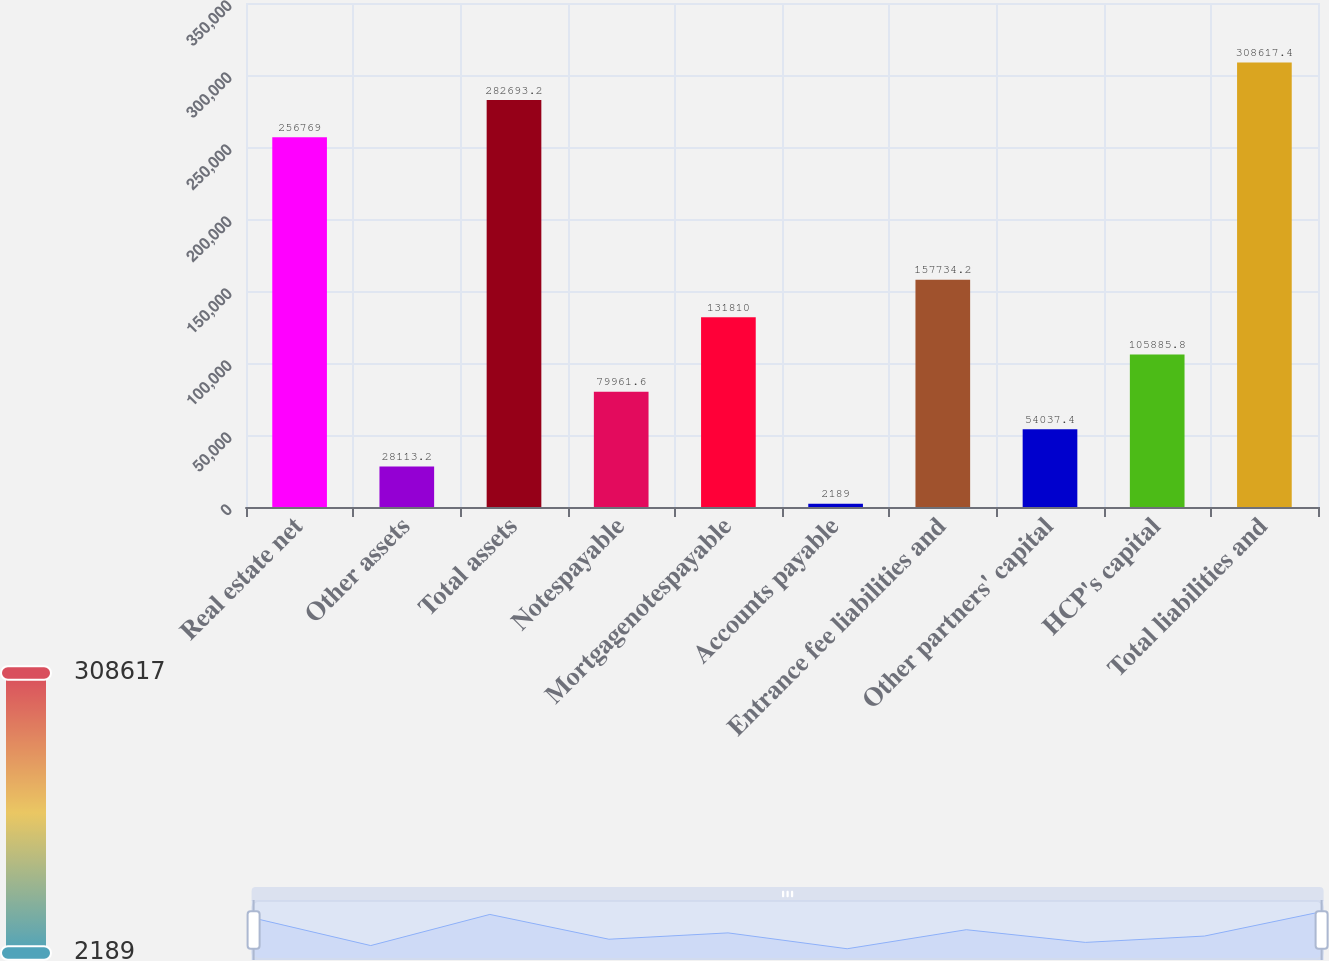<chart> <loc_0><loc_0><loc_500><loc_500><bar_chart><fcel>Real estate net<fcel>Other assets<fcel>Total assets<fcel>Notespayable<fcel>Mortgagenotespayable<fcel>Accounts payable<fcel>Entrance fee liabilities and<fcel>Other partners' capital<fcel>HCP's capital<fcel>Total liabilities and<nl><fcel>256769<fcel>28113.2<fcel>282693<fcel>79961.6<fcel>131810<fcel>2189<fcel>157734<fcel>54037.4<fcel>105886<fcel>308617<nl></chart> 